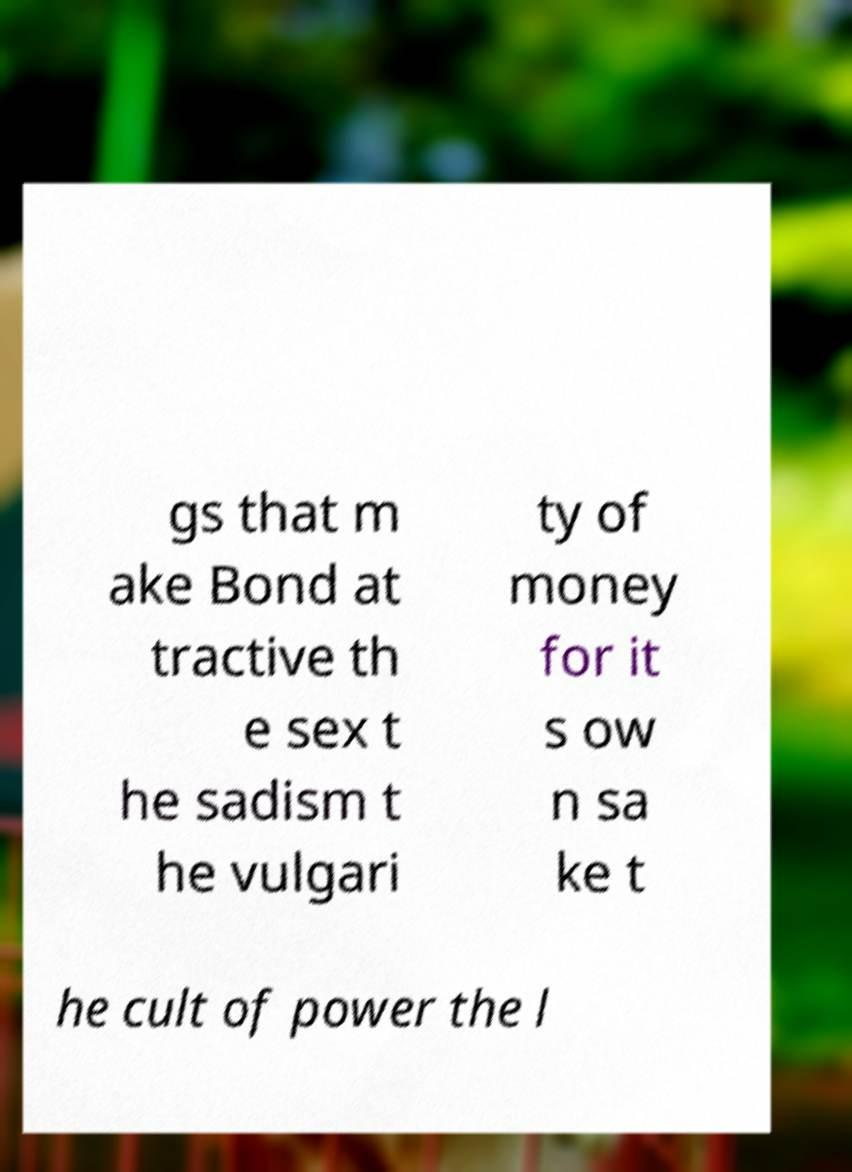Could you extract and type out the text from this image? gs that m ake Bond at tractive th e sex t he sadism t he vulgari ty of money for it s ow n sa ke t he cult of power the l 